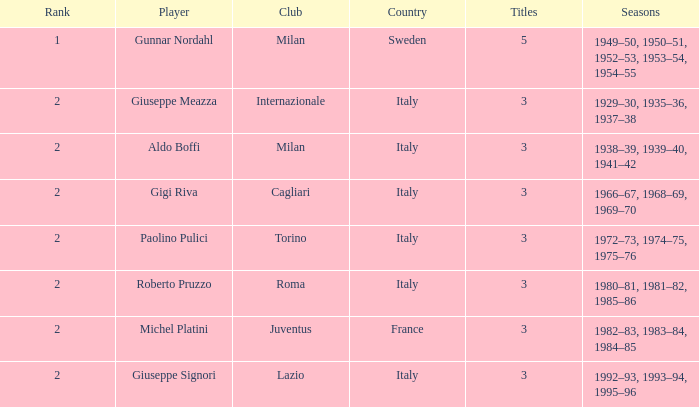What player is ranked 2 and played in the seasons of 1982–83, 1983–84, 1984–85? Michel Platini. 